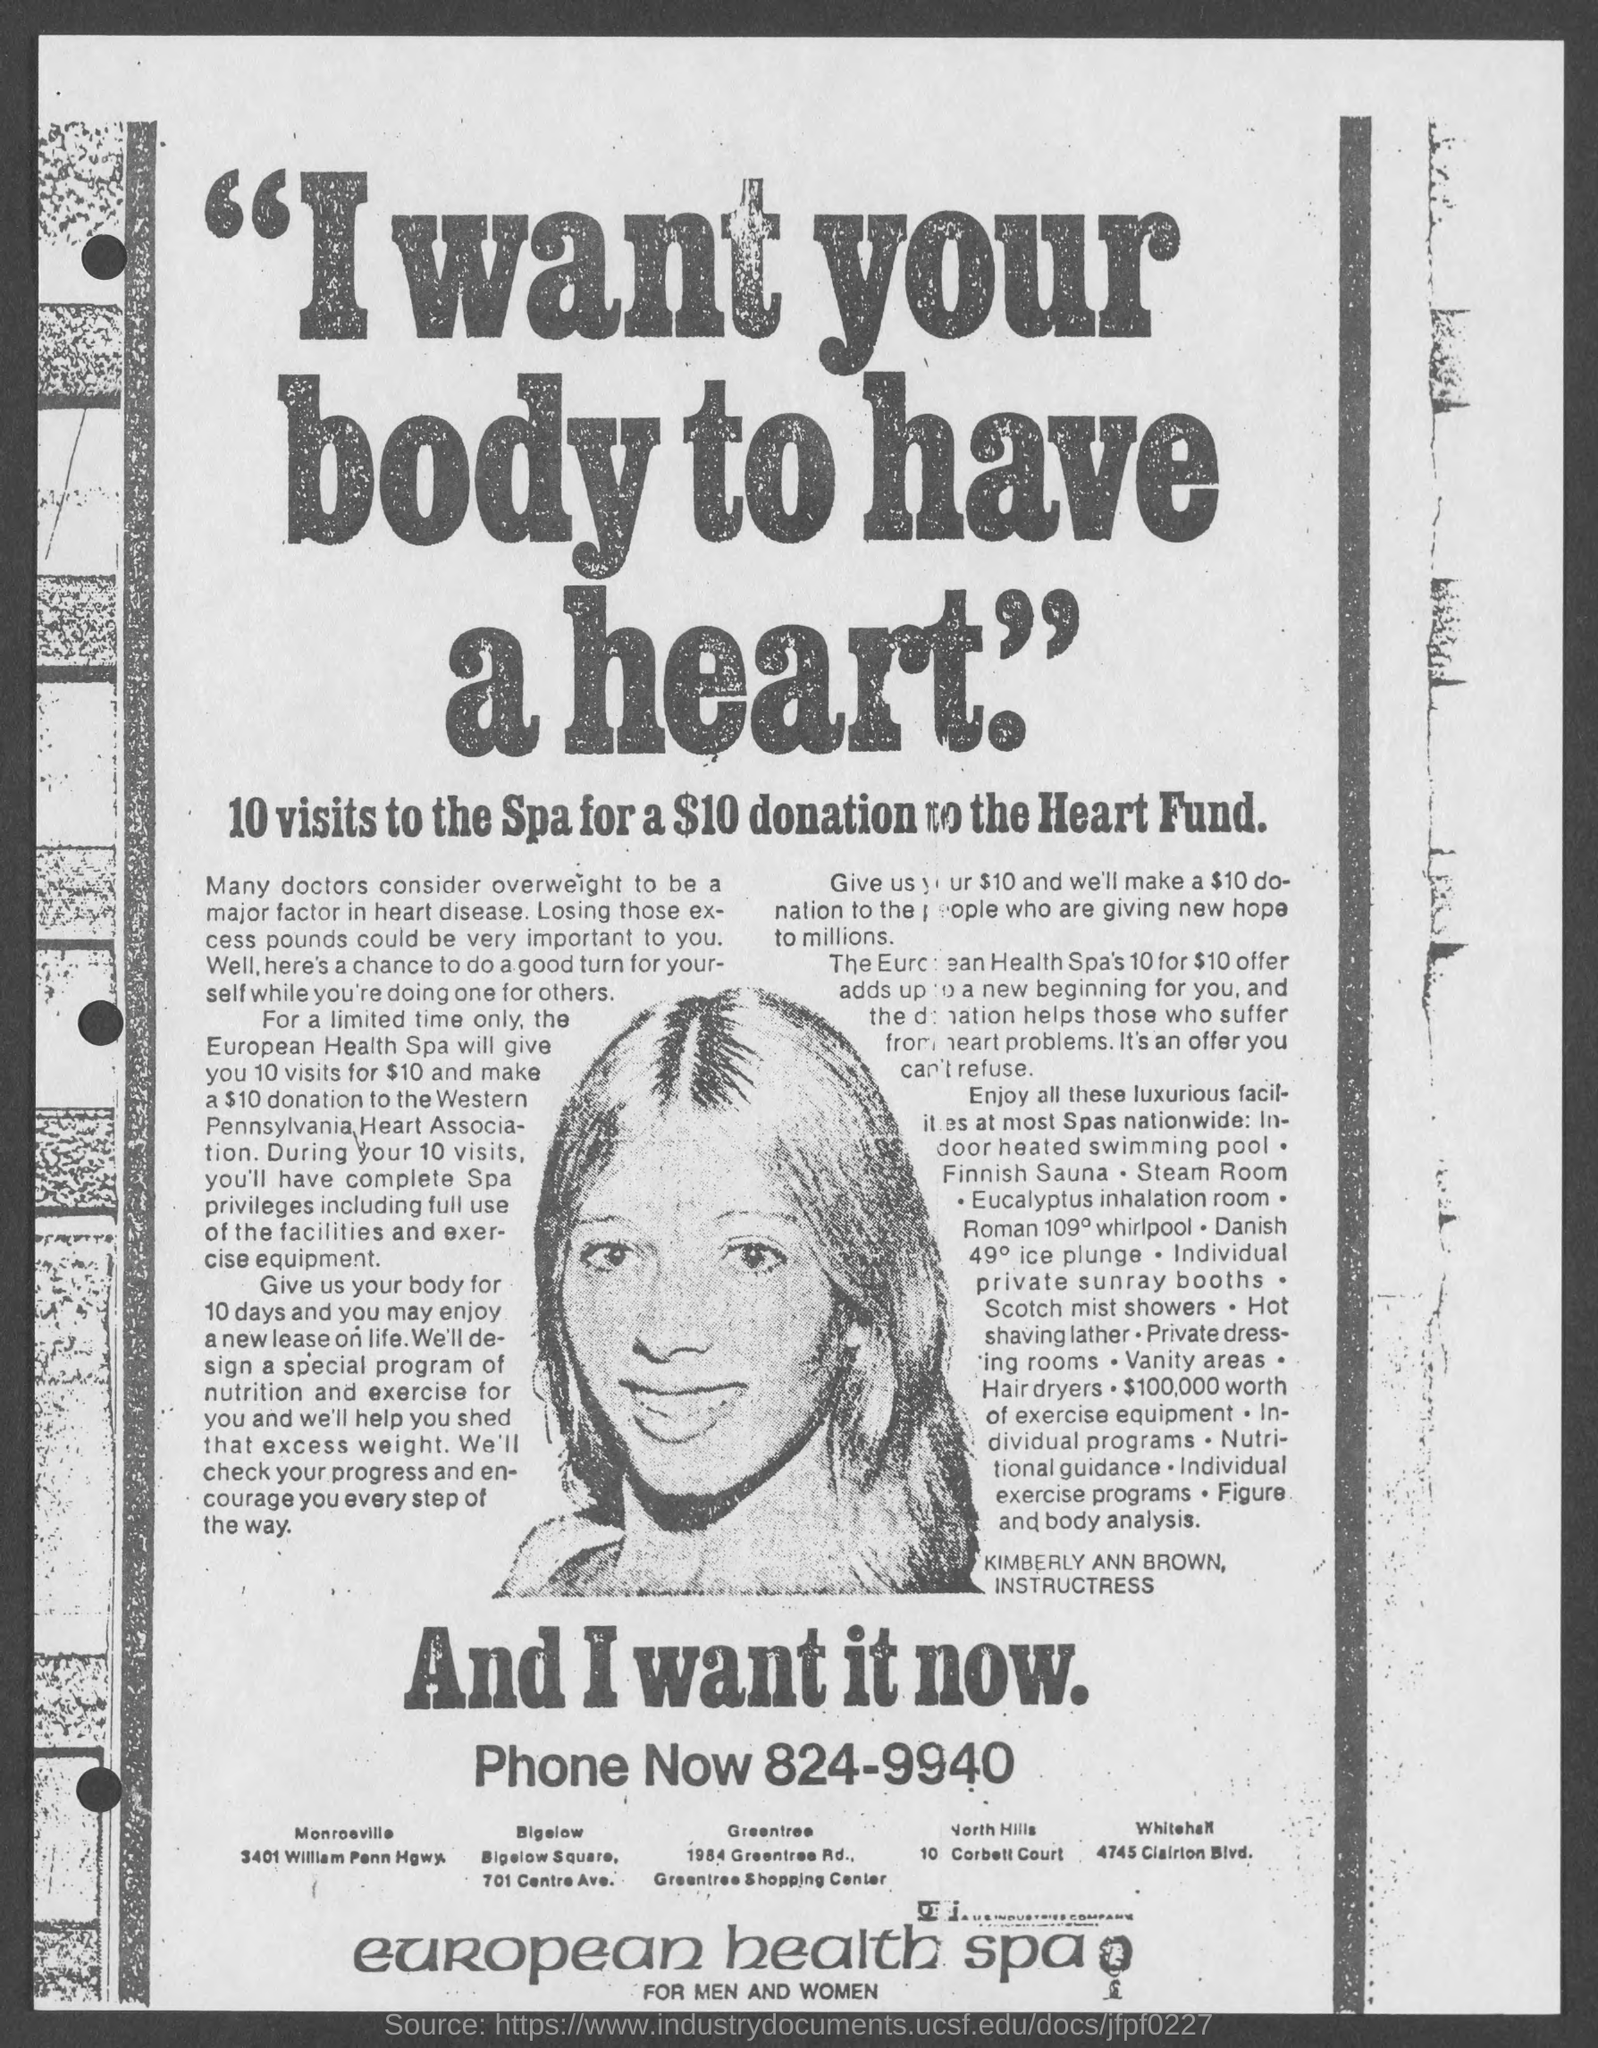Identify some key points in this picture. The phone number is 824-9940. I am donating $10 for 10 visits to a spa. 